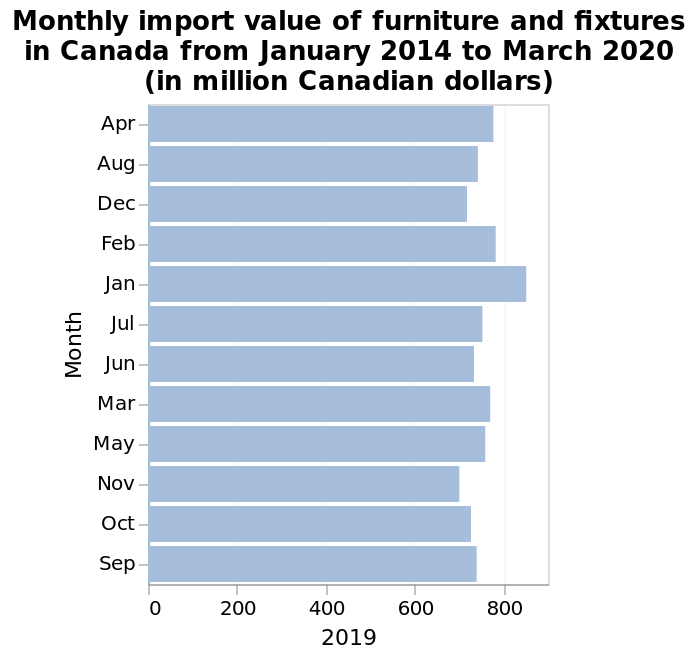<image>
What is the overall trend of furniture imports from January to January?  The overall trend of furniture imports follows a quadratic pattern. Which month experiences the highest number of furniture imports?  January experiences the highest number of furniture imports. What is the pattern of furniture imports throughout the year?  The imports start with a peak in January, reach their lowest point in the middle of the year, and form a quadratic trend from January to January. At what point does the imports reach its lowest level during the year?  The imports reach its lowest level during the mid-year. 